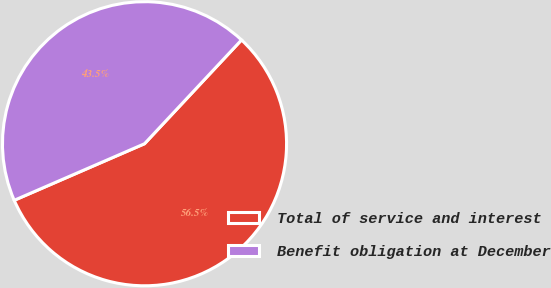Convert chart. <chart><loc_0><loc_0><loc_500><loc_500><pie_chart><fcel>Total of service and interest<fcel>Benefit obligation at December<nl><fcel>56.52%<fcel>43.48%<nl></chart> 